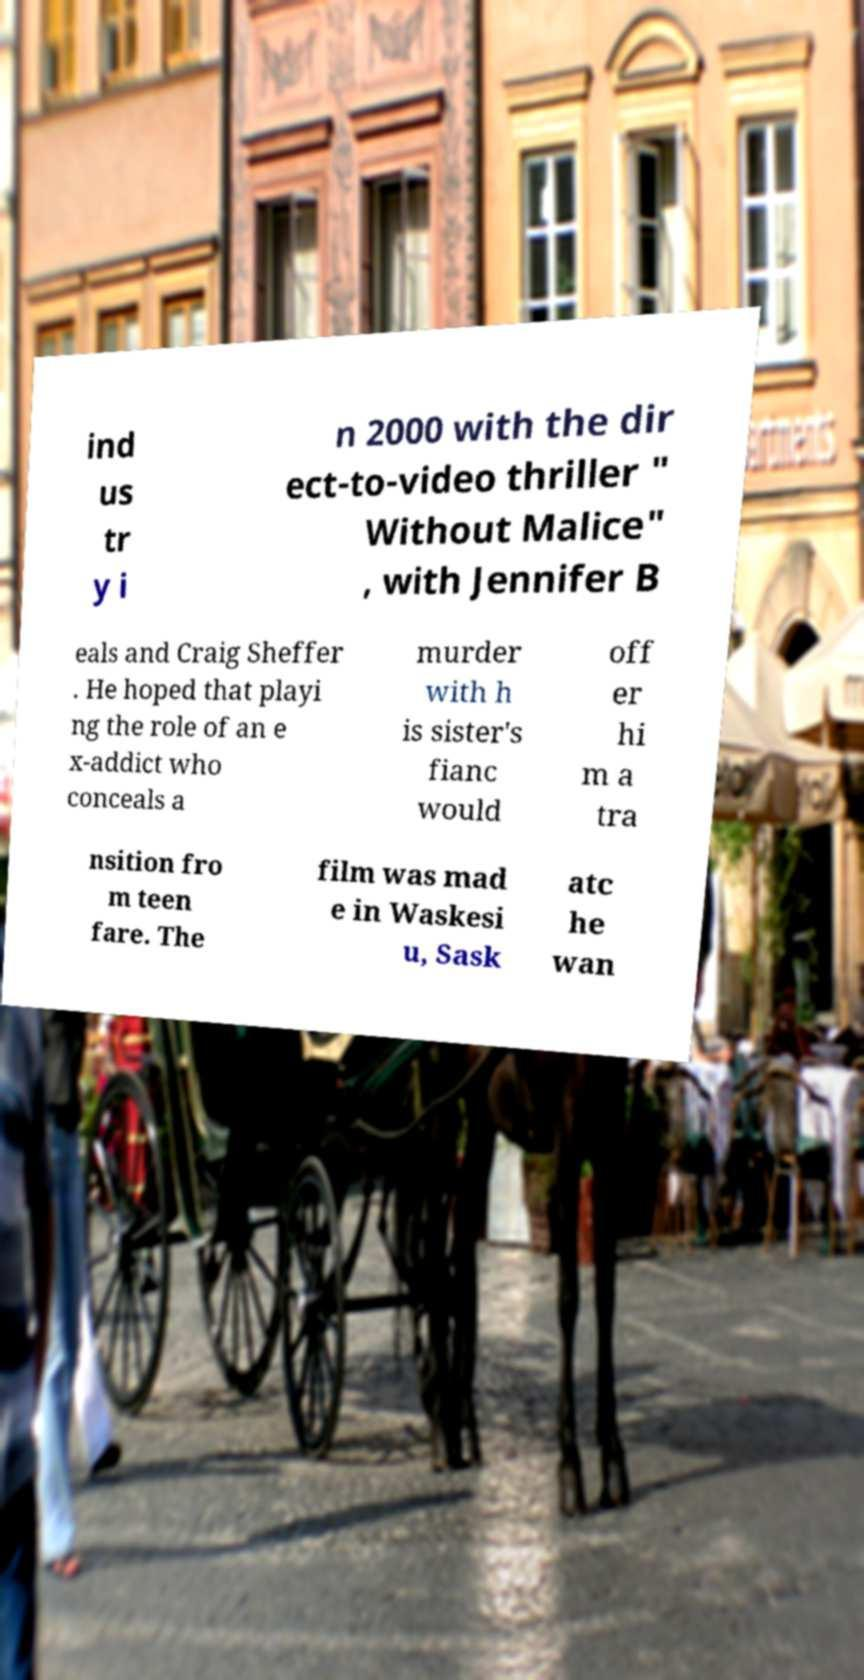Please identify and transcribe the text found in this image. ind us tr y i n 2000 with the dir ect-to-video thriller " Without Malice" , with Jennifer B eals and Craig Sheffer . He hoped that playi ng the role of an e x-addict who conceals a murder with h is sister's fianc would off er hi m a tra nsition fro m teen fare. The film was mad e in Waskesi u, Sask atc he wan 